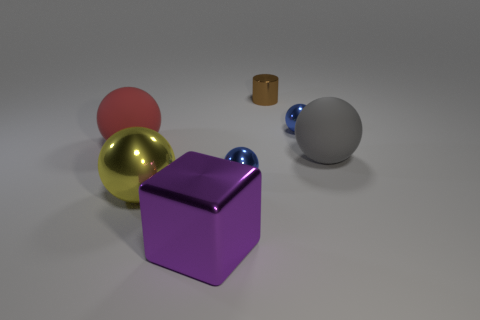Is there any other thing that is the same shape as the brown metal thing?
Your answer should be very brief. No. How many large gray matte objects have the same shape as the red rubber object?
Give a very brief answer. 1. What number of objects are there?
Ensure brevity in your answer.  7. What size is the ball that is behind the large yellow sphere and left of the big purple shiny cube?
Make the answer very short. Large. What is the shape of the gray object that is the same size as the purple block?
Give a very brief answer. Sphere. Is there a large matte ball to the left of the blue metal object right of the tiny brown thing?
Your answer should be compact. Yes. What color is the big shiny object that is the same shape as the large red matte thing?
Your answer should be very brief. Yellow. How many things are tiny metal things in front of the tiny brown thing or small red objects?
Keep it short and to the point. 2. The sphere that is to the right of the blue object that is behind the rubber object that is left of the tiny brown shiny object is made of what material?
Keep it short and to the point. Rubber. Is the number of large metallic spheres left of the purple metallic block greater than the number of big yellow metal spheres that are to the right of the tiny brown metal cylinder?
Keep it short and to the point. Yes. 